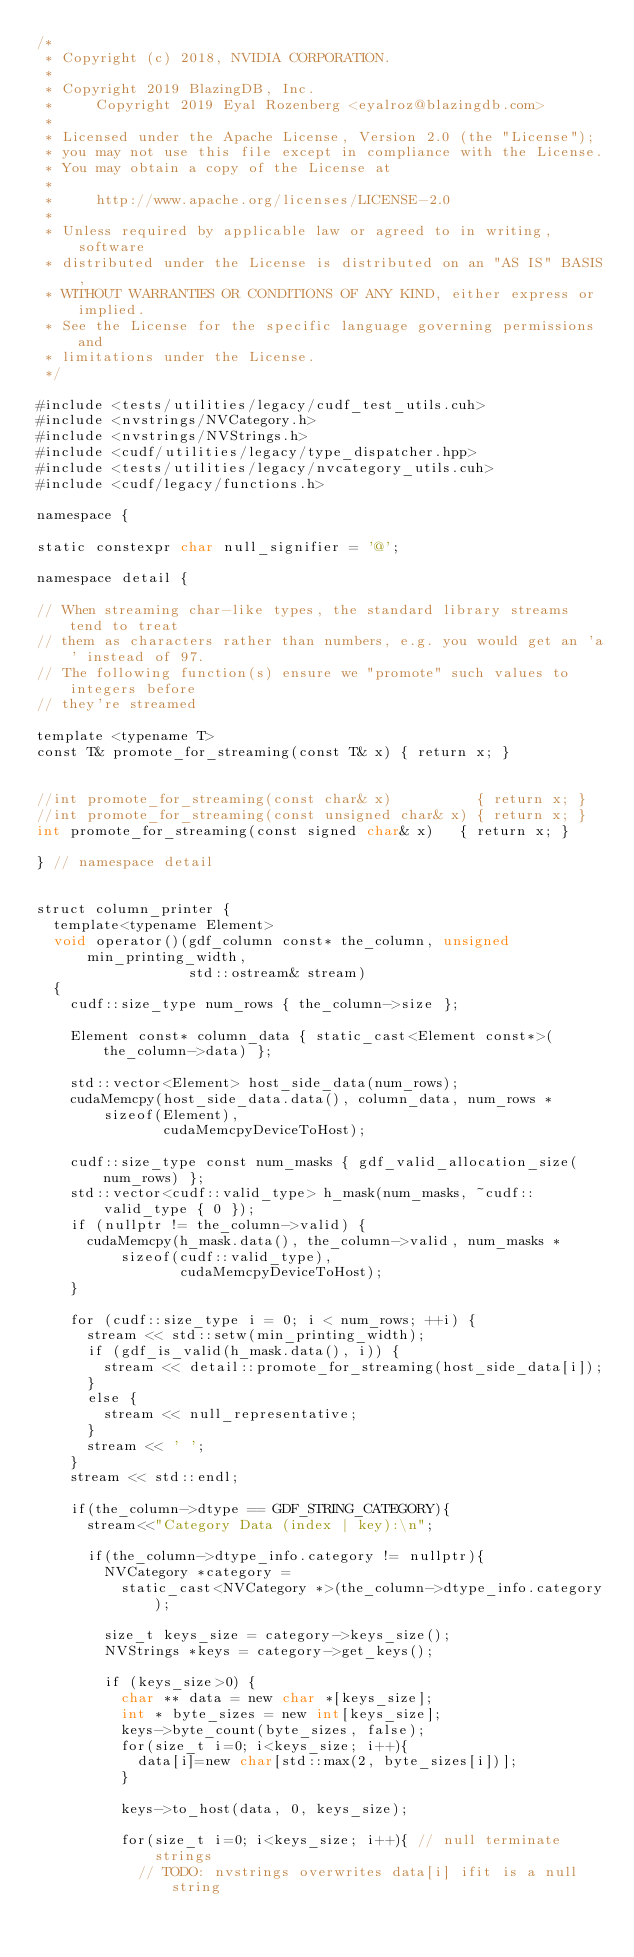Convert code to text. <code><loc_0><loc_0><loc_500><loc_500><_Cuda_>/*
 * Copyright (c) 2018, NVIDIA CORPORATION.
 *
 * Copyright 2019 BlazingDB, Inc.
 *     Copyright 2019 Eyal Rozenberg <eyalroz@blazingdb.com>
 *
 * Licensed under the Apache License, Version 2.0 (the "License");
 * you may not use this file except in compliance with the License.
 * You may obtain a copy of the License at
 *
 *     http://www.apache.org/licenses/LICENSE-2.0
 *
 * Unless required by applicable law or agreed to in writing, software
 * distributed under the License is distributed on an "AS IS" BASIS,
 * WITHOUT WARRANTIES OR CONDITIONS OF ANY KIND, either express or implied.
 * See the License for the specific language governing permissions and
 * limitations under the License.
 */

#include <tests/utilities/legacy/cudf_test_utils.cuh>
#include <nvstrings/NVCategory.h>
#include <nvstrings/NVStrings.h>
#include <cudf/utilities/legacy/type_dispatcher.hpp>
#include <tests/utilities/legacy/nvcategory_utils.cuh>
#include <cudf/legacy/functions.h>

namespace {

static constexpr char null_signifier = '@';

namespace detail {

// When streaming char-like types, the standard library streams tend to treat
// them as characters rather than numbers, e.g. you would get an 'a' instead of 97.
// The following function(s) ensure we "promote" such values to integers before
// they're streamed

template <typename T>
const T& promote_for_streaming(const T& x) { return x; }


//int promote_for_streaming(const char& x)          { return x; }
//int promote_for_streaming(const unsigned char& x) { return x; }
int promote_for_streaming(const signed char& x)   { return x; }

} // namespace detail


struct column_printer {
  template<typename Element>
  void operator()(gdf_column const* the_column, unsigned min_printing_width,
                  std::ostream& stream)
  {
    cudf::size_type num_rows { the_column->size };

    Element const* column_data { static_cast<Element const*>(the_column->data) };

    std::vector<Element> host_side_data(num_rows);
    cudaMemcpy(host_side_data.data(), column_data, num_rows * sizeof(Element),
               cudaMemcpyDeviceToHost);

    cudf::size_type const num_masks { gdf_valid_allocation_size(num_rows) };
    std::vector<cudf::valid_type> h_mask(num_masks, ~cudf::valid_type { 0 });
    if (nullptr != the_column->valid) {
      cudaMemcpy(h_mask.data(), the_column->valid, num_masks * sizeof(cudf::valid_type),
                 cudaMemcpyDeviceToHost);
    }

    for (cudf::size_type i = 0; i < num_rows; ++i) {
      stream << std::setw(min_printing_width);
      if (gdf_is_valid(h_mask.data(), i)) {
        stream << detail::promote_for_streaming(host_side_data[i]);
      }
      else {
        stream << null_representative;
      }
      stream << ' ';
    }
    stream << std::endl;

    if(the_column->dtype == GDF_STRING_CATEGORY){
      stream<<"Category Data (index | key):\n";

      if(the_column->dtype_info.category != nullptr){
        NVCategory *category =
          static_cast<NVCategory *>(the_column->dtype_info.category);
        
        size_t keys_size = category->keys_size();
        NVStrings *keys = category->get_keys();
        
        if (keys_size>0) {
          char ** data = new char *[keys_size];
          int * byte_sizes = new int[keys_size];
          keys->byte_count(byte_sizes, false);
          for(size_t i=0; i<keys_size; i++){
            data[i]=new char[std::max(2, byte_sizes[i])];
          }

          keys->to_host(data, 0, keys_size);

          for(size_t i=0; i<keys_size; i++){ // null terminate strings
            // TODO: nvstrings overwrites data[i] ifit is a null string</code> 